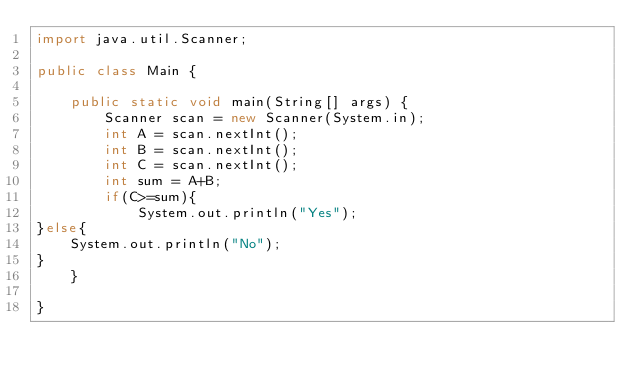<code> <loc_0><loc_0><loc_500><loc_500><_Java_>import java.util.Scanner;

public class Main {

	public static void main(String[] args) {
		Scanner scan = new Scanner(System.in);
		int A = scan.nextInt();
		int B = scan.nextInt();
		int C = scan.nextInt();
		int sum = A+B;
		if(C>=sum){
			System.out.println("Yes");
}else{
	System.out.println("No");
}
	}

}
</code> 